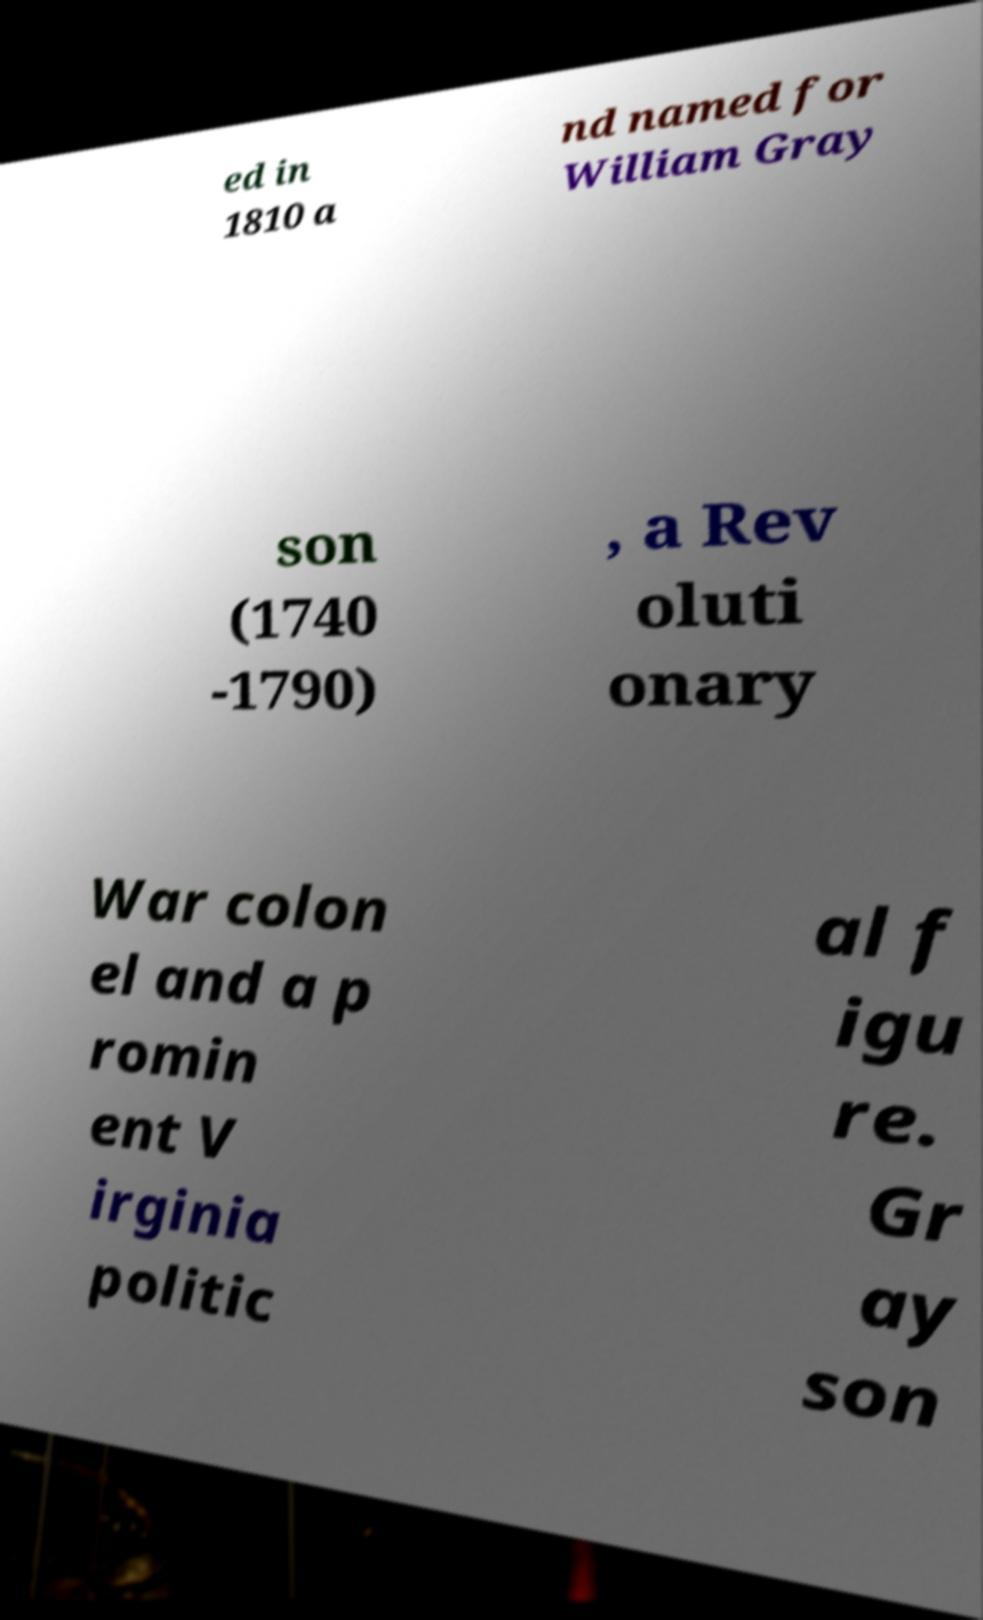Could you extract and type out the text from this image? ed in 1810 a nd named for William Gray son (1740 -1790) , a Rev oluti onary War colon el and a p romin ent V irginia politic al f igu re. Gr ay son 